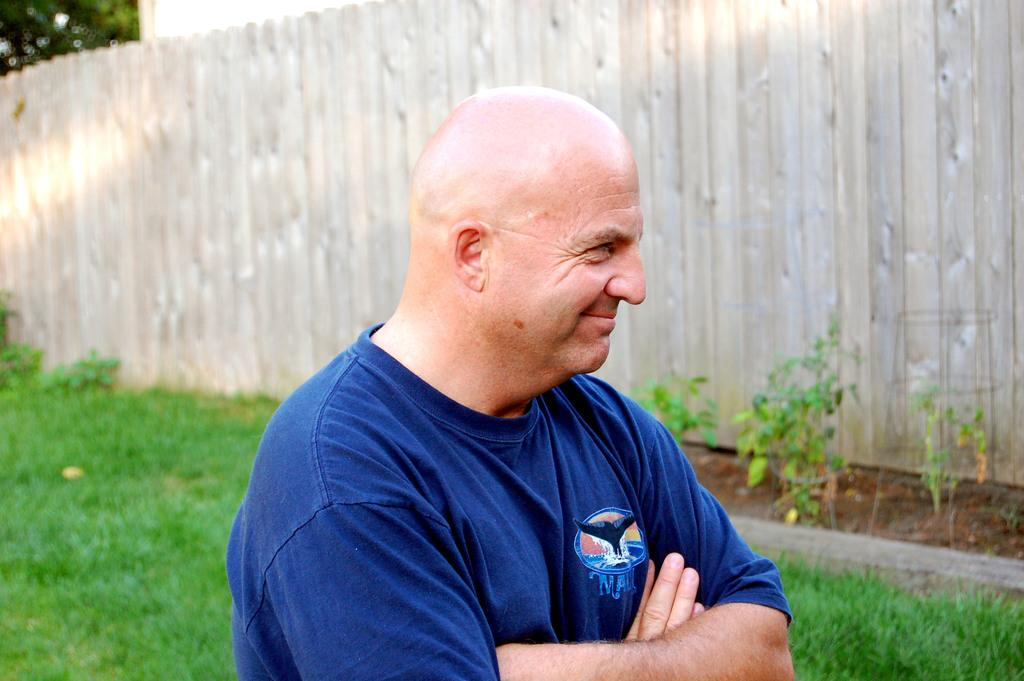Who is present in the image? There is a man in the image. What is the man doing in the image? The man is smiling in the image. What is the man wearing in the image? The man is wearing a blue shirt in the image. What type of environment is visible in the man in? There is grass visible in the image, suggesting an outdoor setting. What can be seen in the background? There is a wall and plants in the background of the image. What type of horse can be seen in the image? There is no horse present in the image. What does the flag represent in the image? There is no flag present in the image. 